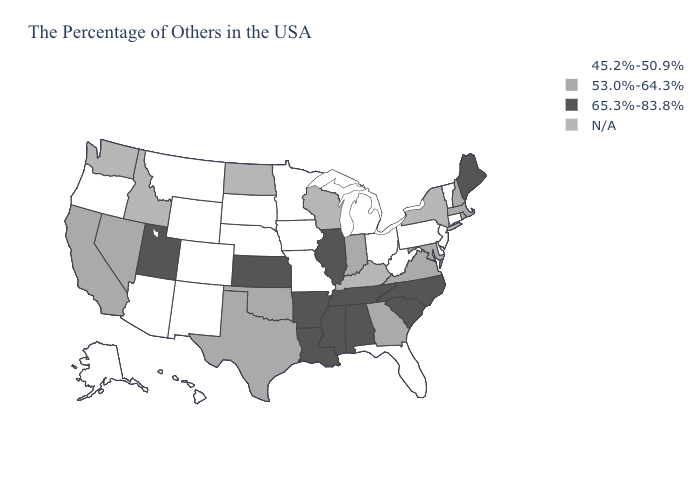Name the states that have a value in the range 53.0%-64.3%?
Give a very brief answer. Massachusetts, Rhode Island, New Hampshire, Maryland, Virginia, Georgia, Indiana, Oklahoma, Texas, Nevada, California. Does Illinois have the highest value in the USA?
Be succinct. Yes. Does Illinois have the highest value in the MidWest?
Concise answer only. Yes. Name the states that have a value in the range 65.3%-83.8%?
Quick response, please. Maine, North Carolina, South Carolina, Alabama, Tennessee, Illinois, Mississippi, Louisiana, Arkansas, Kansas, Utah. Name the states that have a value in the range 53.0%-64.3%?
Quick response, please. Massachusetts, Rhode Island, New Hampshire, Maryland, Virginia, Georgia, Indiana, Oklahoma, Texas, Nevada, California. What is the value of Alaska?
Answer briefly. 45.2%-50.9%. What is the highest value in states that border Idaho?
Be succinct. 65.3%-83.8%. Which states hav the highest value in the MidWest?
Quick response, please. Illinois, Kansas. Which states have the highest value in the USA?
Concise answer only. Maine, North Carolina, South Carolina, Alabama, Tennessee, Illinois, Mississippi, Louisiana, Arkansas, Kansas, Utah. Name the states that have a value in the range N/A?
Quick response, please. New York, Kentucky, Wisconsin, North Dakota, Idaho, Washington. What is the highest value in the West ?
Be succinct. 65.3%-83.8%. Name the states that have a value in the range 45.2%-50.9%?
Quick response, please. Vermont, Connecticut, New Jersey, Delaware, Pennsylvania, West Virginia, Ohio, Florida, Michigan, Missouri, Minnesota, Iowa, Nebraska, South Dakota, Wyoming, Colorado, New Mexico, Montana, Arizona, Oregon, Alaska, Hawaii. What is the value of Pennsylvania?
Keep it brief. 45.2%-50.9%. Name the states that have a value in the range 65.3%-83.8%?
Quick response, please. Maine, North Carolina, South Carolina, Alabama, Tennessee, Illinois, Mississippi, Louisiana, Arkansas, Kansas, Utah. 